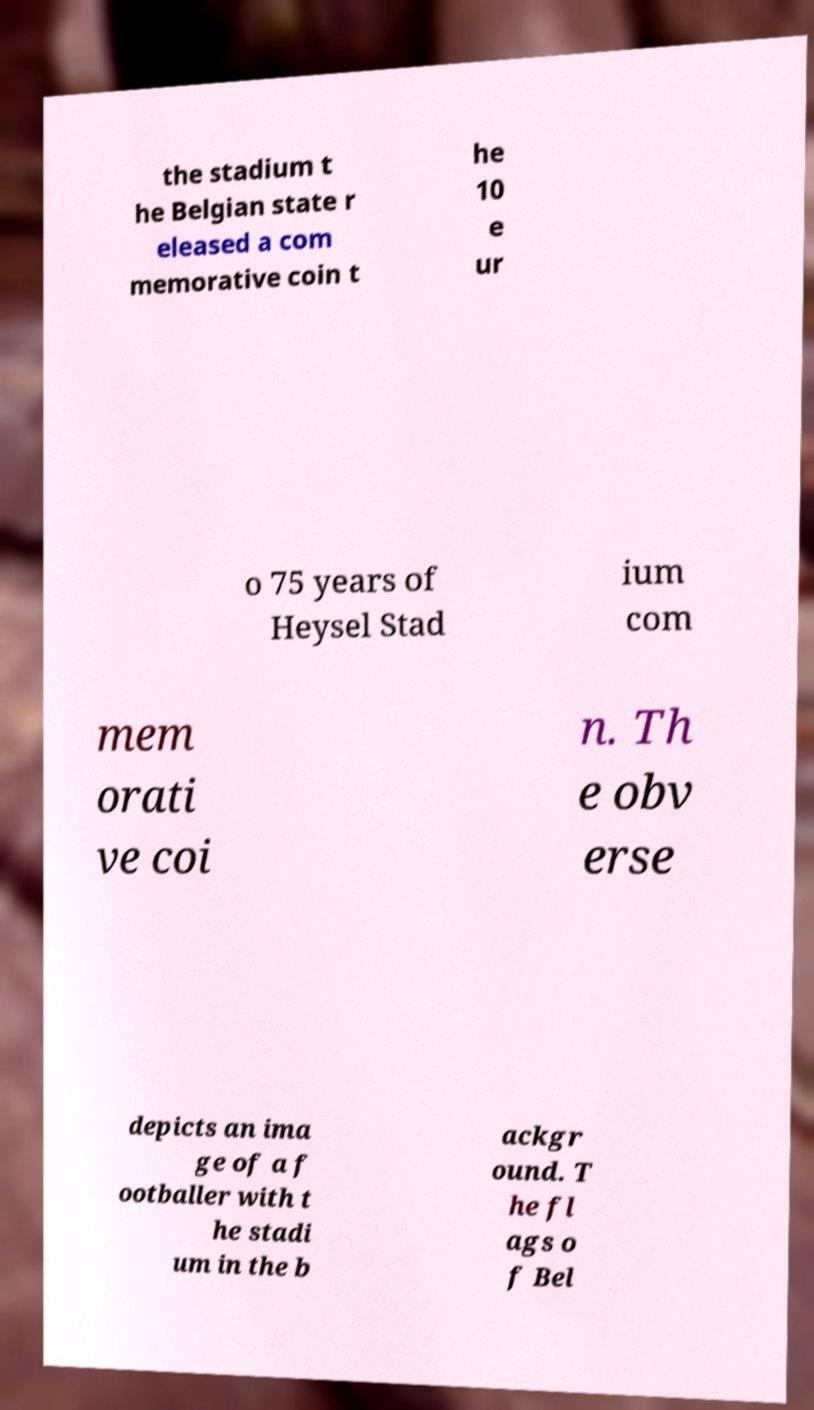For documentation purposes, I need the text within this image transcribed. Could you provide that? the stadium t he Belgian state r eleased a com memorative coin t he 10 e ur o 75 years of Heysel Stad ium com mem orati ve coi n. Th e obv erse depicts an ima ge of a f ootballer with t he stadi um in the b ackgr ound. T he fl ags o f Bel 